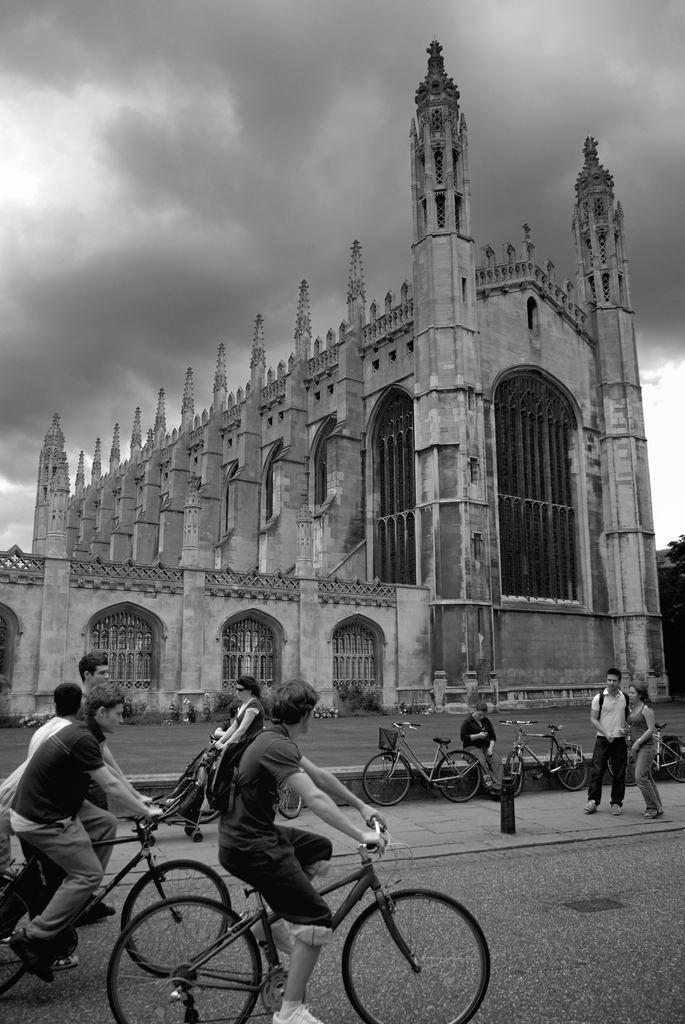What are the people in the image doing? There are people riding bicycles in the image. What else can be seen on the road in the image? There are people standing on the road in the image. What structure is located beside the road in the image? There is a building beside the road in the image. How would you describe the sky in the image? The sky appears drowsy in the image. What type of veil can be seen covering the building in the image? There is no veil covering the building in the image; it is visible without any obstruction. 